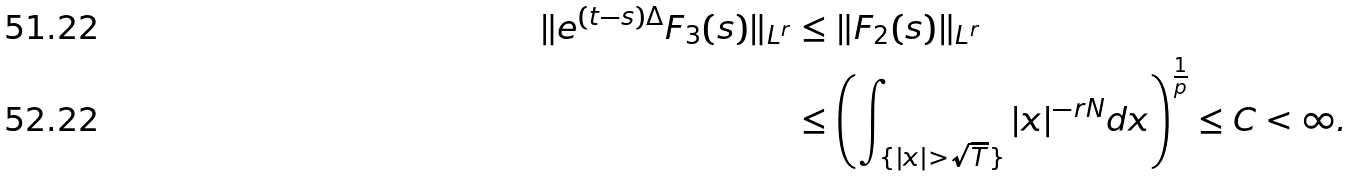<formula> <loc_0><loc_0><loc_500><loc_500>\| e ^ { ( t - s ) \Delta } F _ { 3 } ( s ) \| _ { L ^ { r } } & \leq \| F _ { 2 } ( s ) \| _ { L ^ { r } } \\ & \leq \left ( \int _ { \{ | x | > \sqrt { T } \} } | x | ^ { - r N } d x \right ) ^ { \frac { 1 } { p } } \leq C < \infty .</formula> 